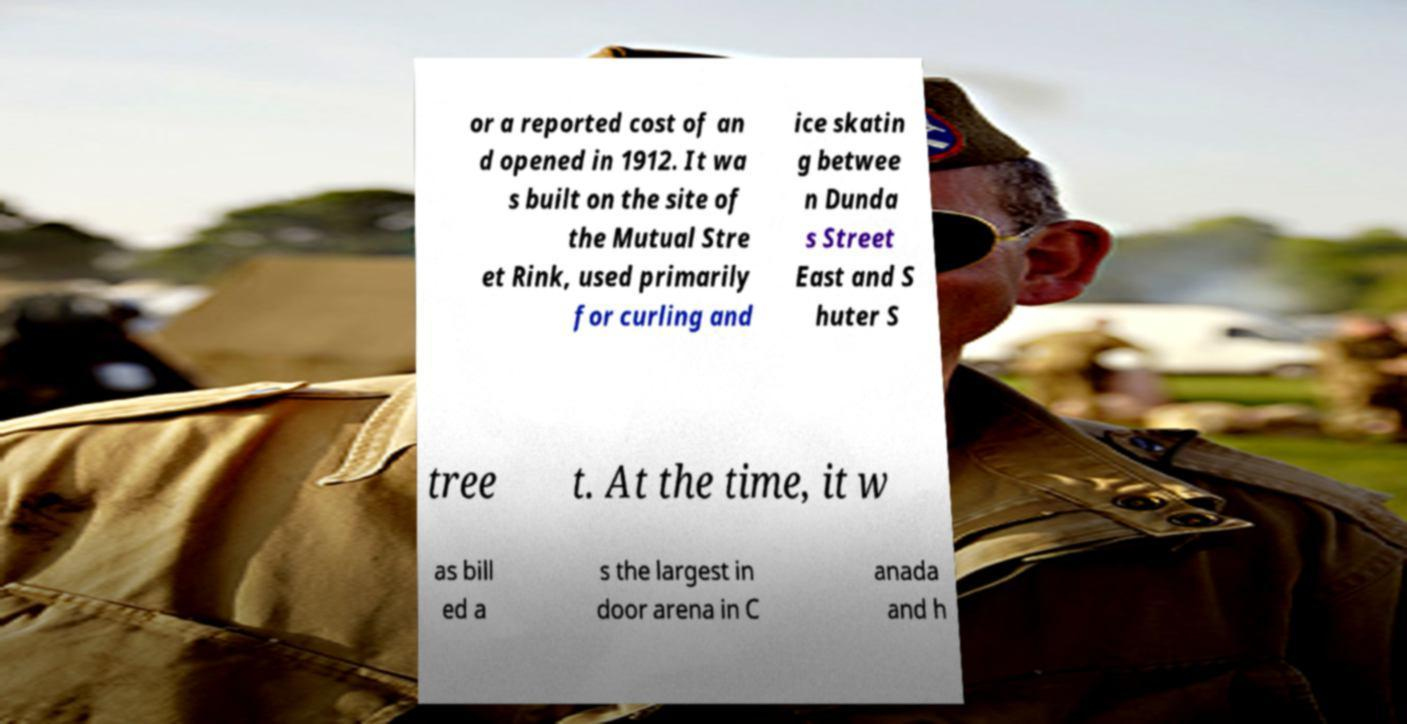Please identify and transcribe the text found in this image. or a reported cost of an d opened in 1912. It wa s built on the site of the Mutual Stre et Rink, used primarily for curling and ice skatin g betwee n Dunda s Street East and S huter S tree t. At the time, it w as bill ed a s the largest in door arena in C anada and h 